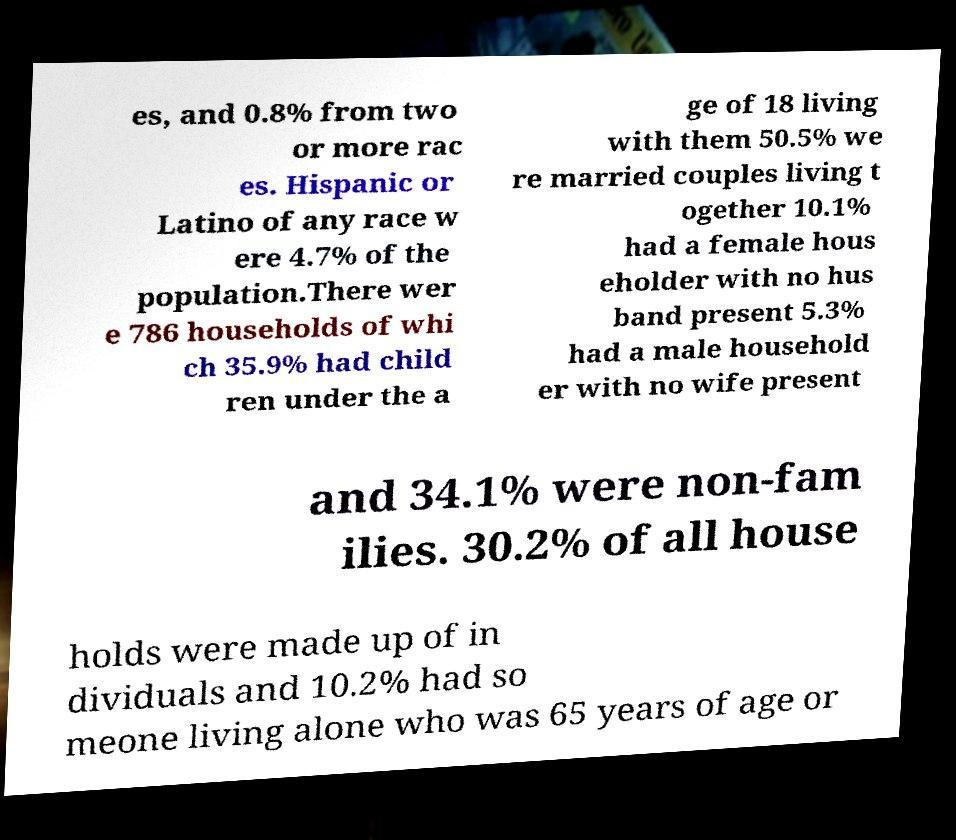For documentation purposes, I need the text within this image transcribed. Could you provide that? es, and 0.8% from two or more rac es. Hispanic or Latino of any race w ere 4.7% of the population.There wer e 786 households of whi ch 35.9% had child ren under the a ge of 18 living with them 50.5% we re married couples living t ogether 10.1% had a female hous eholder with no hus band present 5.3% had a male household er with no wife present and 34.1% were non-fam ilies. 30.2% of all house holds were made up of in dividuals and 10.2% had so meone living alone who was 65 years of age or 